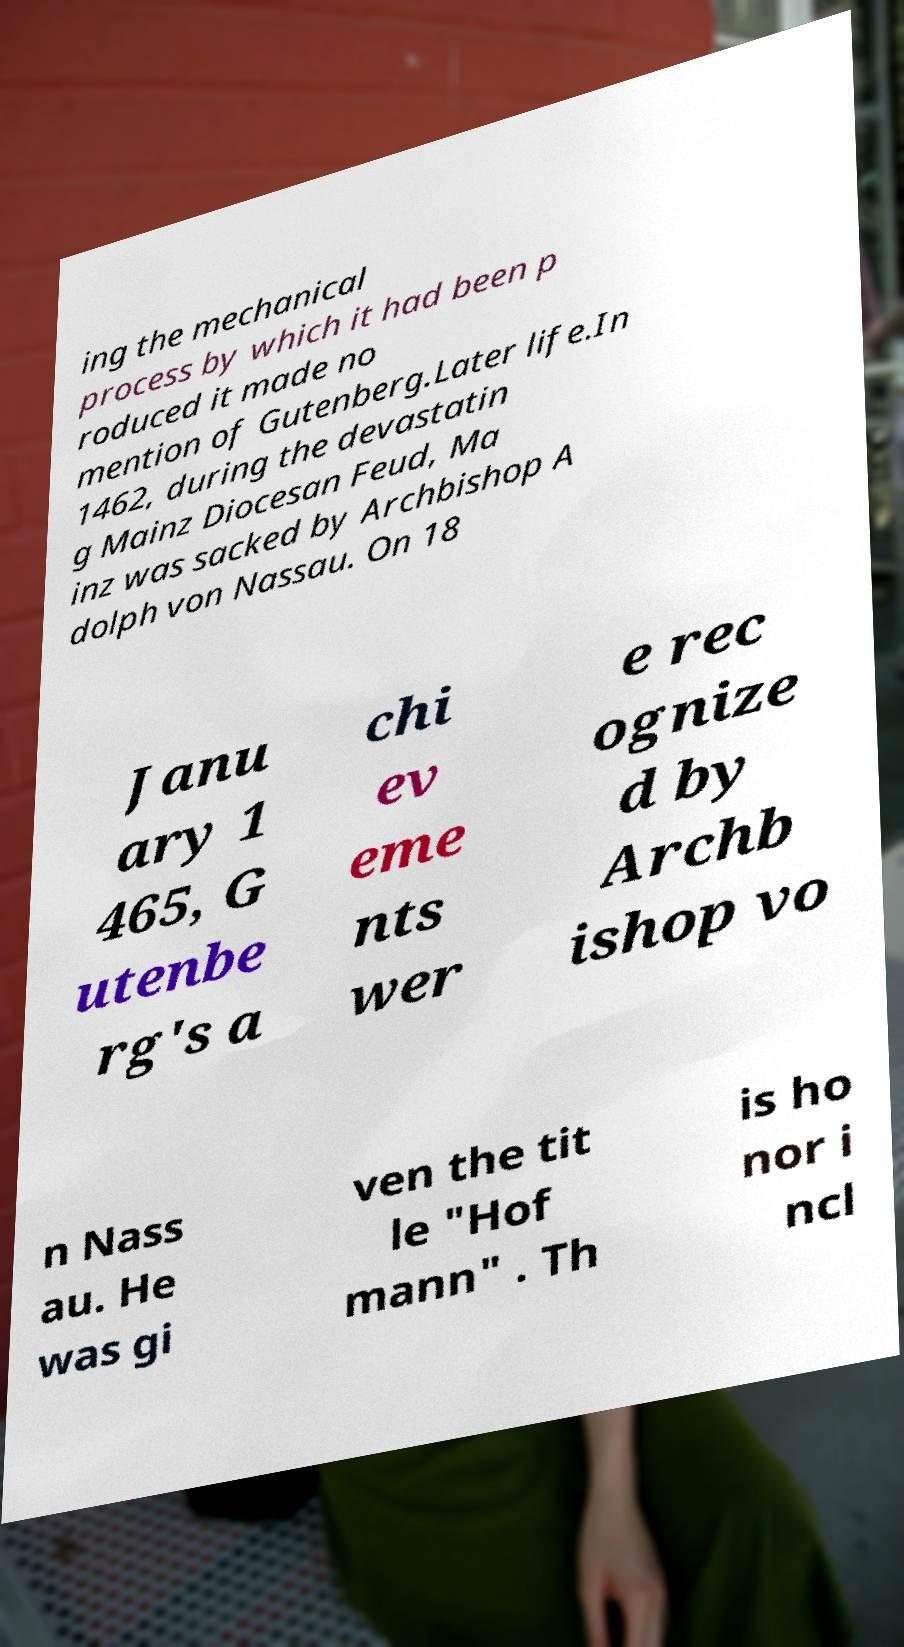What messages or text are displayed in this image? I need them in a readable, typed format. ing the mechanical process by which it had been p roduced it made no mention of Gutenberg.Later life.In 1462, during the devastatin g Mainz Diocesan Feud, Ma inz was sacked by Archbishop A dolph von Nassau. On 18 Janu ary 1 465, G utenbe rg's a chi ev eme nts wer e rec ognize d by Archb ishop vo n Nass au. He was gi ven the tit le "Hof mann" . Th is ho nor i ncl 